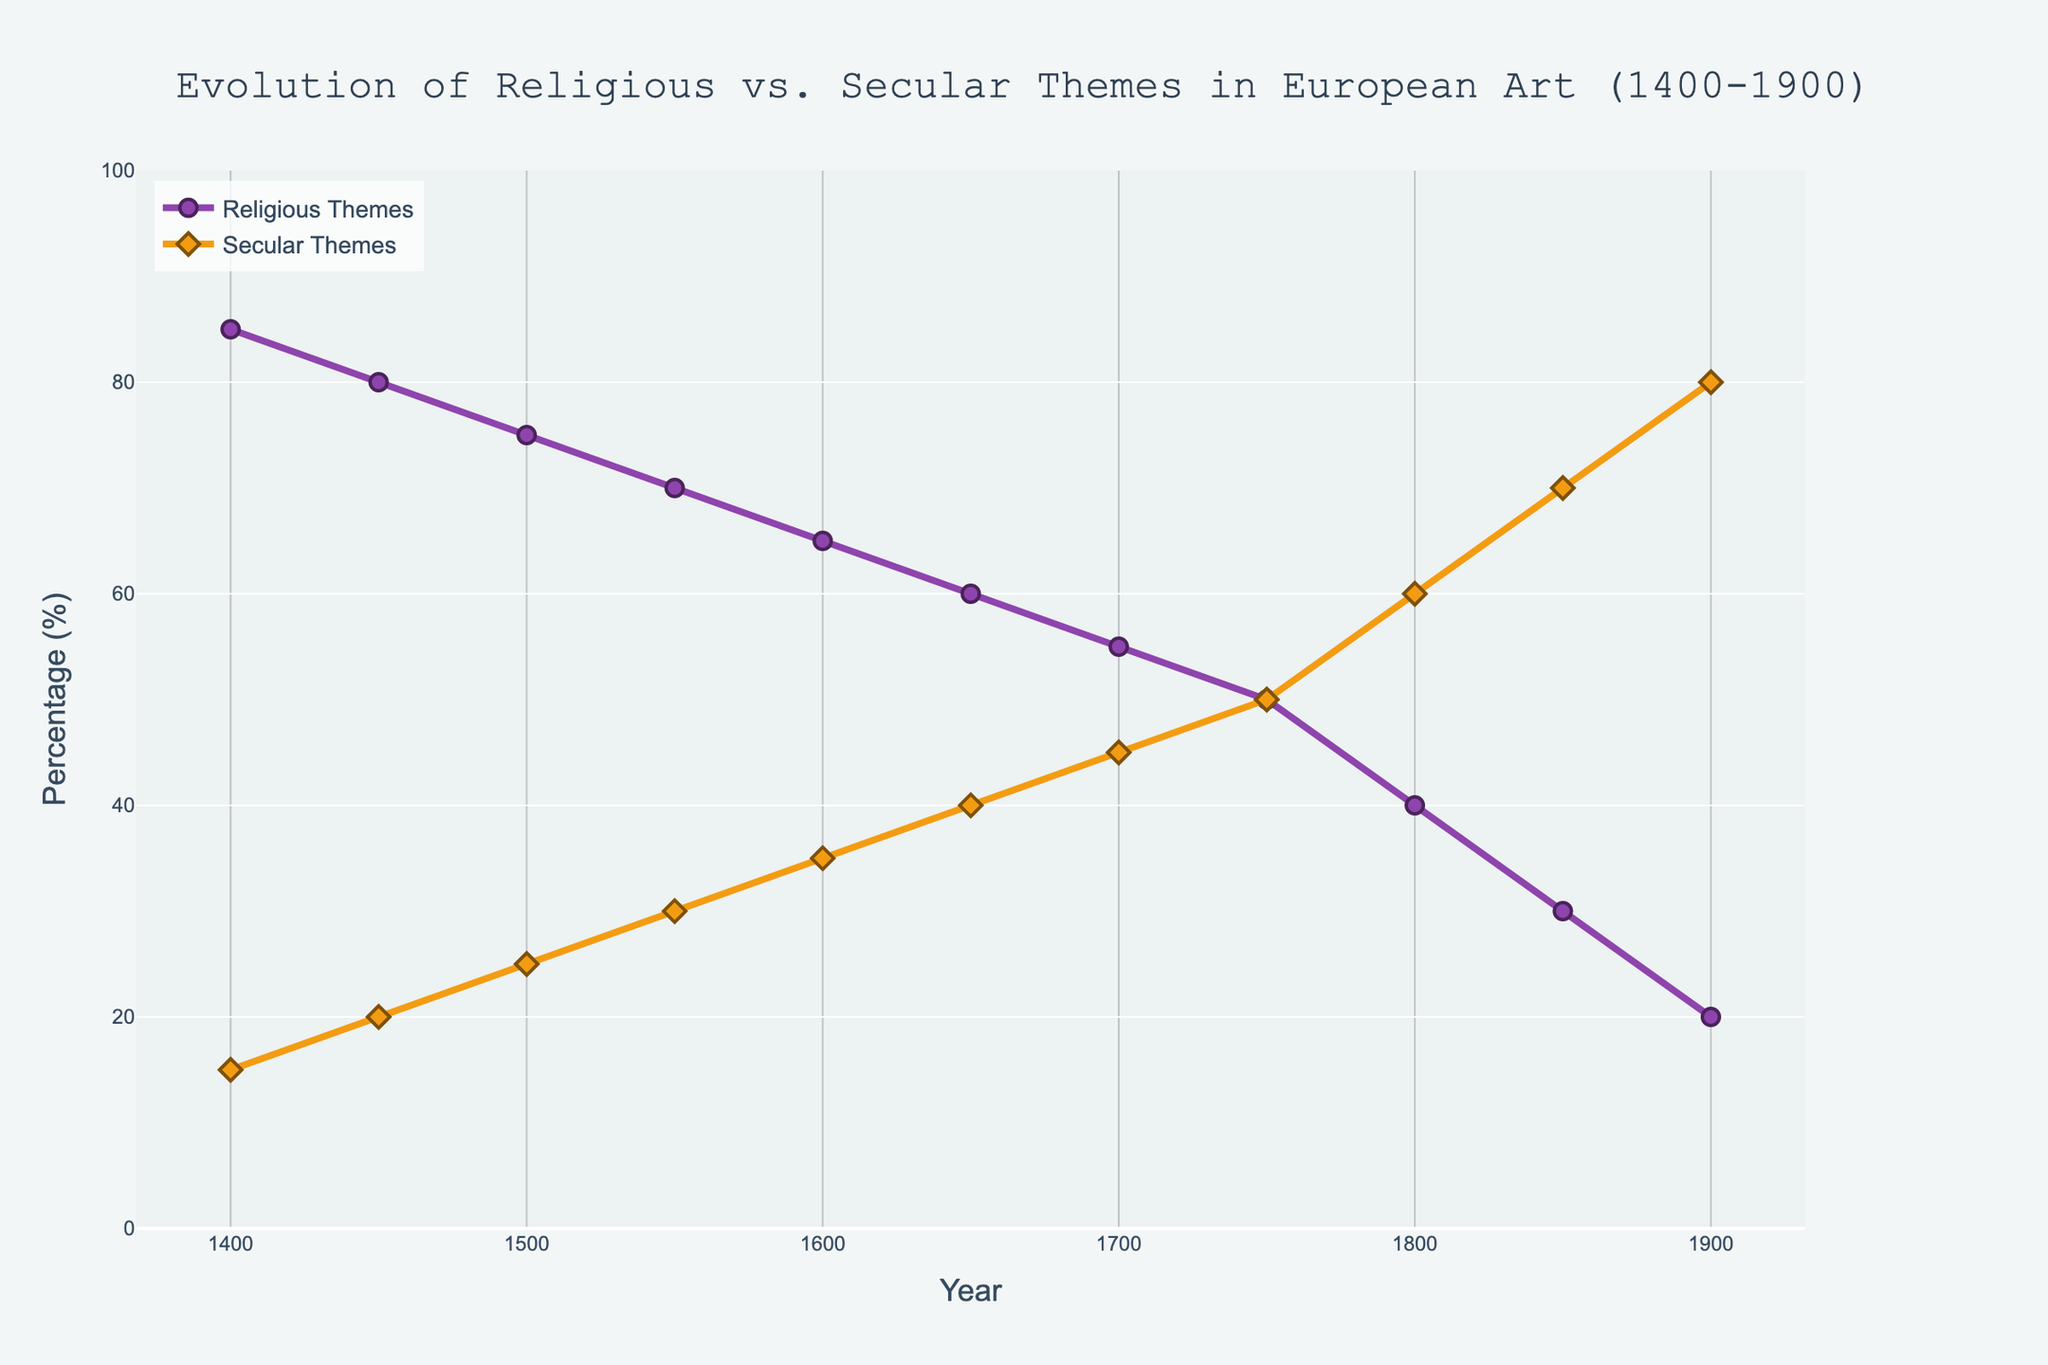What is the general trend of religious themes in European art from 1400 to 1900? Look at the line representing religious themes from 1400 to 1900; it shows a decreasing trend. Starting at 85% in 1400 and reducing to 20% by 1900.
Answer: Decreasing Which year shows the equal percentage of religious and secular themes? Find the year where the religious and secular themes intersection point occurs. From the figure, this happens at the 1750 mark, where both themes are at 50%.
Answer: 1750 What is the percentage change in secular themes from 1400 to 1800? Calculate the difference in secular themes between 1800 and 1400, which are 60% and 15% respectively. The percentage change = (60 - 15) / 15 * 100%.
Answer: 300% During which century did secular themes surpass religious themes? Identify the period during which the lines for secular and religious themes crossed. This happens around the middle of the 18th century (1750s).
Answer: 18th century In which year was the difference between religious and secular themes the greatest? Calculate the differences between religious and secular themes for each year. The year with the largest difference is 1400, with religious at 85% and secular at 15%, giving a difference of 70%.
Answer: 1400 Which theme had the higher percentage in 1700, and by how much? In 1700, compare the values of religious (55%) and secular (45%) themes. Religious themes were higher by 10%.
Answer: Religious, by 10% How do the percentages of religious and secular themes in 1900 compare to each other? In 1900, the chart shows religious themes at 20% and secular themes at 80%. It's clear that secular themes are higher.
Answer: Secular themes are higher by 60% What was the percentage difference between religious and secular themes in 1650? For 1650, religious themes are at 60% and secular themes are at 40%. The difference is 60% - 40% = 20%.
Answer: 20% Describe the intersection points observed in the chart. From the chart, there is one intersection point where the lines for religious and secular themes cross each other. This occurs in 1750 at 50%.
Answer: One intersection point at 1750 Which theme dominates European art in 1450, and what is its percentage? In 1450, the values for religious and secular themes are 80% and 20% respectively. Religious themes dominate.
Answer: Religious, 80% 